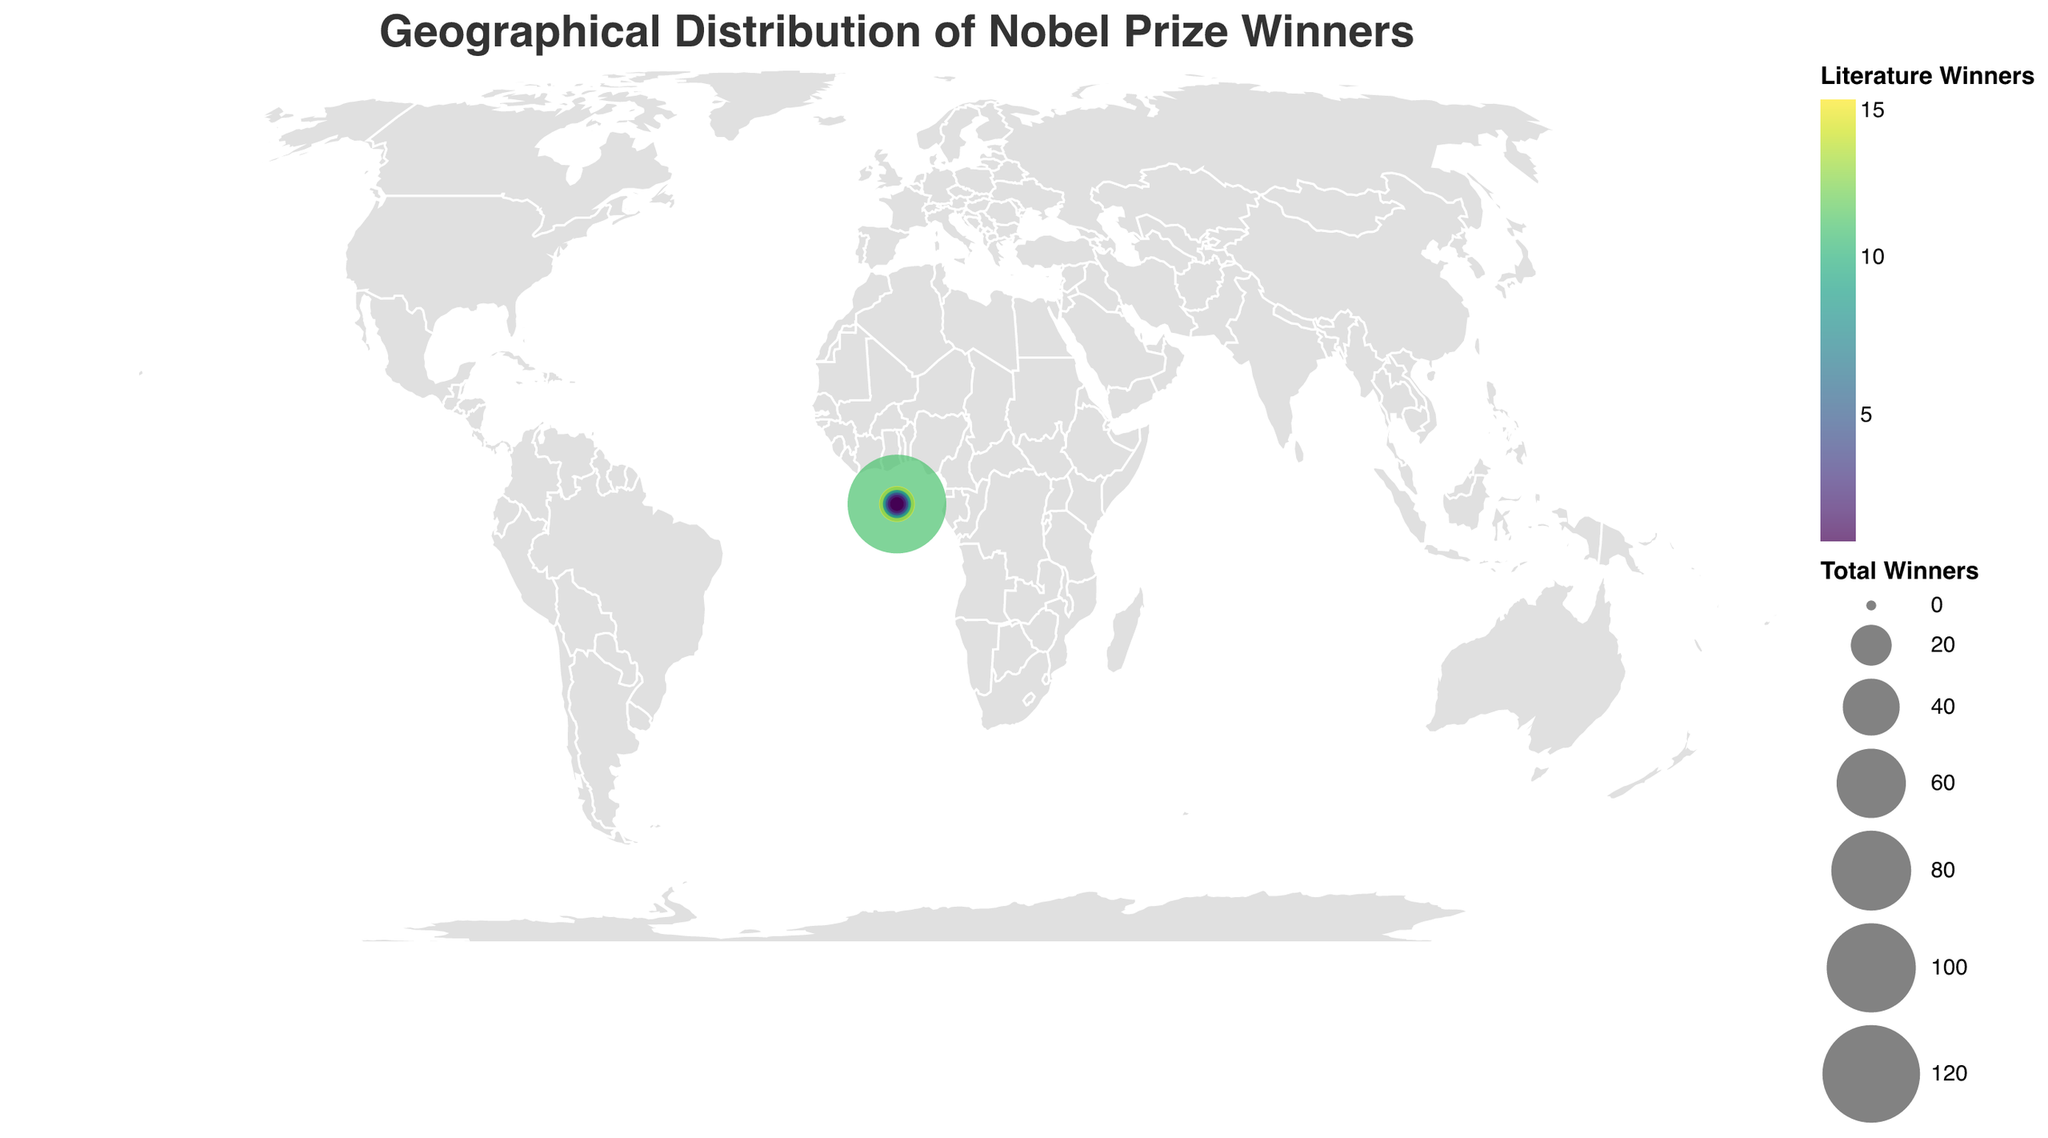Which country has the highest number of total Nobel Prize winners? Looking at the plot, the United States has the largest circle, indicating the highest total number of winners.
Answer: United States Which country has more winners in Literature, France or the United Kingdom? France is represented with 15 Literature Winners compared to 12 for the United Kingdom.
Answer: France How many countries have at least one Journalism winner? Observing the tooltip information, the countries with at least one Journalism winner are the United States, United Kingdom, Germany, Poland, and Canada.
Answer: 5 Which country has the second-highest number of winners in Literature? France has the highest with 15, while the United Kingdom is next with 12 Literature Winners.
Answer: United Kingdom What is the total number of Nobel Prize winners for Germany? The tooltip for Germany indicates it has 9 total winners.
Answer: 9 How many countries have a total of exactly 5 winners? The countries with exactly 5 total winners are Spain and Poland.
Answer: 2 Among the countries listed, which one has the smallest circle on the plot? The tooltip reveals that Egypt, China, India, Australia, and Nigeria each have 1 total winner, represented as the smallest circles.
Answer: Egypt, China, India, Australia, Nigeria What is the combined number of Literature and Journalism winners for Canada? Canada has 2 Literature Winners and 1 Journalism Winner, making the combined total 2 + 1 = 3.
Answer: 3 Which countries have no Journalism winners but have Literature winners? From the tooltip, France, Sweden, Italy, Spain, Russia, Japan, Ireland, Colombia, Chile, South Africa, Egypt, China, India, Australia, and Nigeria all have Literature Winners only.
Answer: 15 countries Comparing the United States and the United Kingdom, which has more total winners? The tooltip shows the United States with 123 total winners and the United Kingdom with 14. 123 is greater than 14.
Answer: United States 